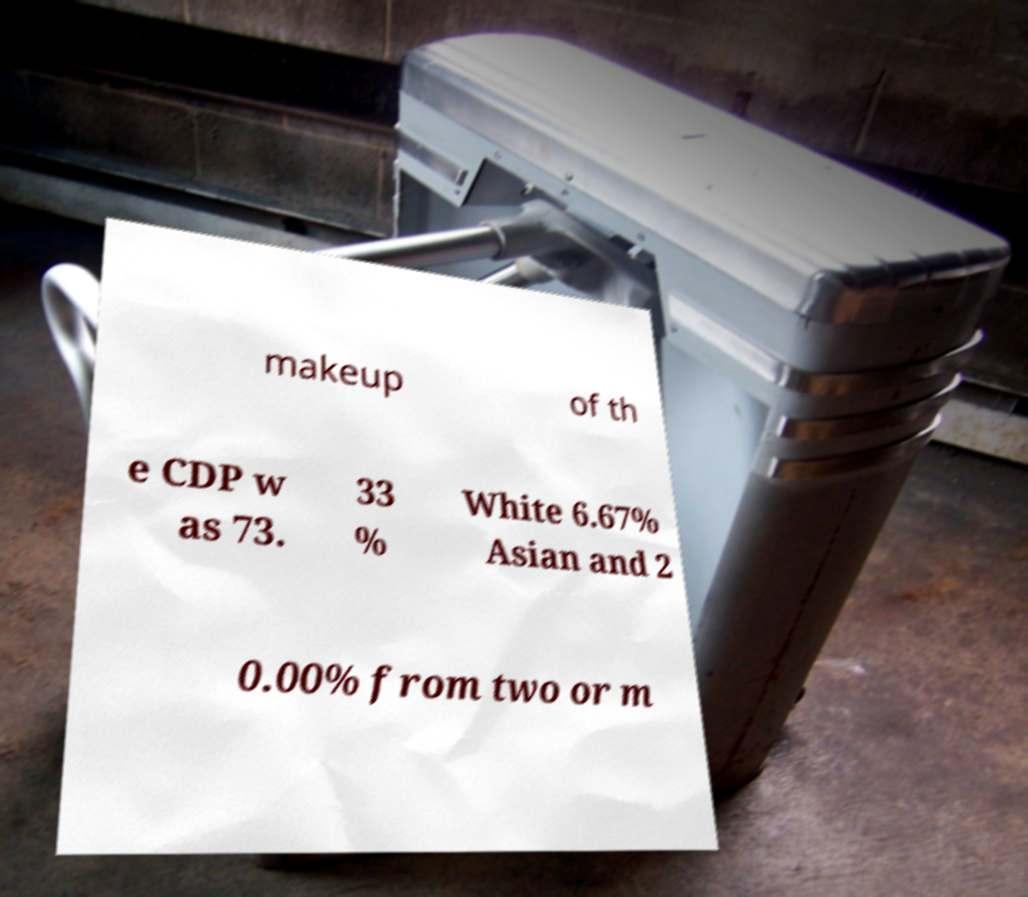Can you read and provide the text displayed in the image?This photo seems to have some interesting text. Can you extract and type it out for me? makeup of th e CDP w as 73. 33 % White 6.67% Asian and 2 0.00% from two or m 